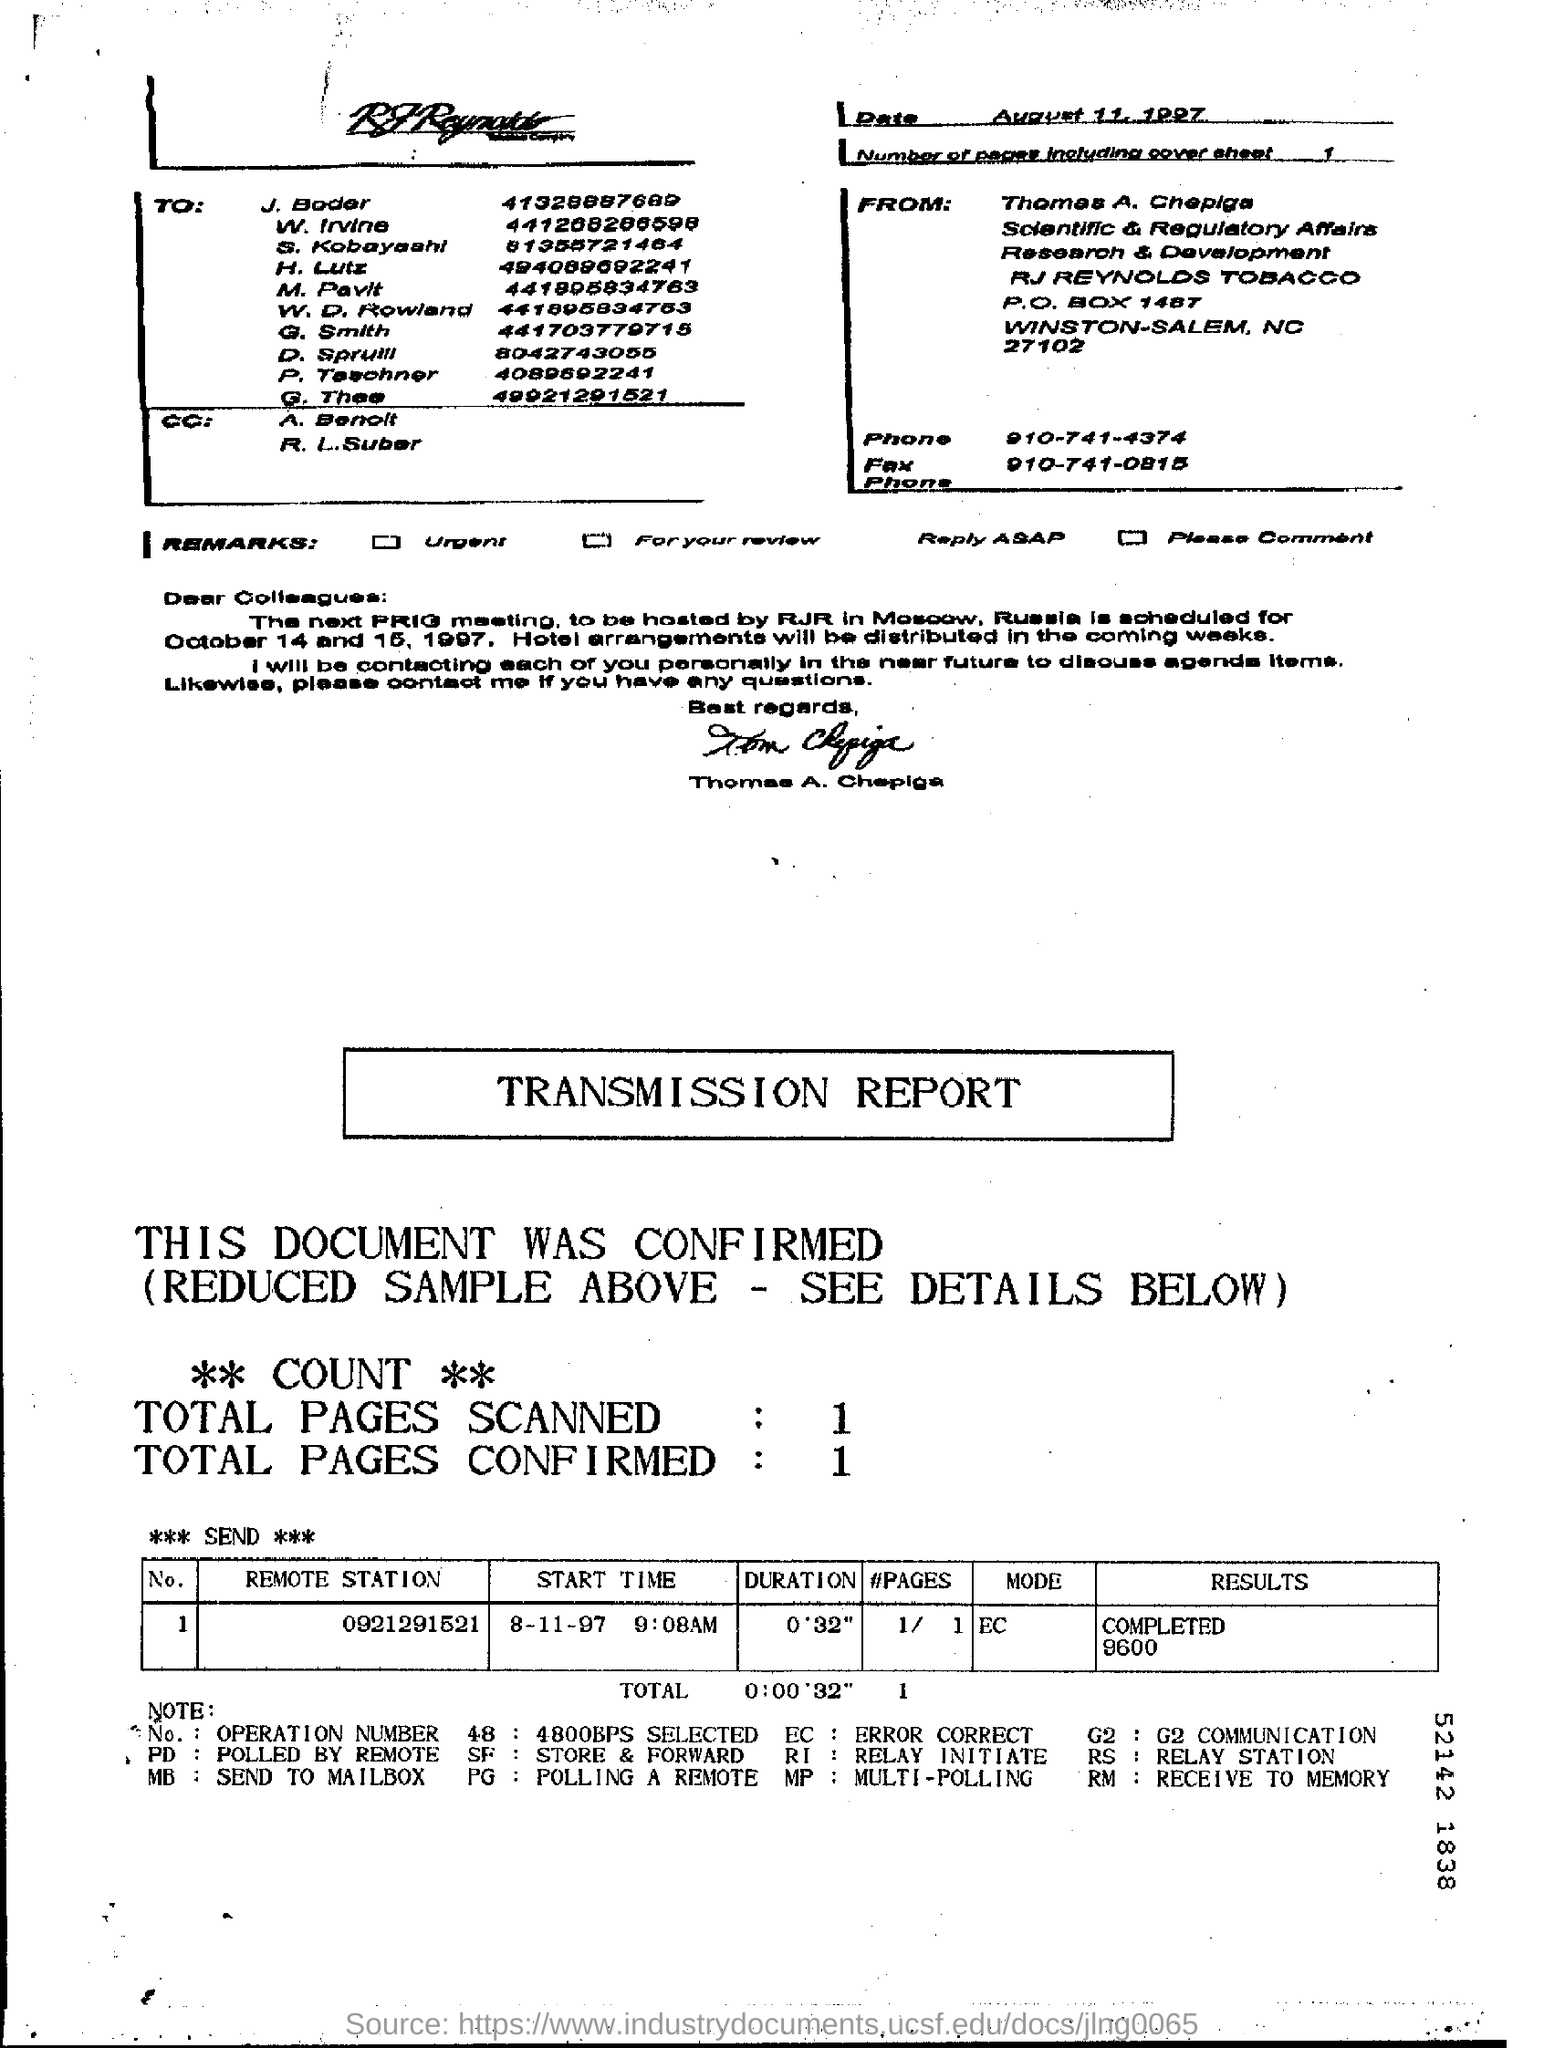What is the date mentioned in the cover sheet?
Keep it short and to the point. August 11, 1997. How many pages are scanned as part of this transmission?
Keep it short and to the point. 1. What is the first name of the person who has sent this communication?
Provide a succinct answer. Thomas. What are the total number of pages confirmed?
Offer a terse response. 1. What is sender's phone number?
Offer a very short reply. 910-741-4374. 